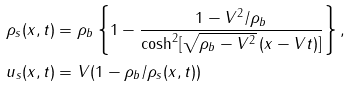<formula> <loc_0><loc_0><loc_500><loc_500>\rho _ { s } ( x , t ) & = \rho _ { b } \left \{ 1 - \frac { 1 - V ^ { 2 } / \rho _ { b } } { \cosh ^ { 2 } [ \sqrt { \rho _ { b } - V ^ { 2 } } \, ( x - V t ) ] } \right \} , \\ u _ { s } ( x , t ) & = V ( 1 - \rho _ { b } / \rho _ { s } ( x , t ) )</formula> 